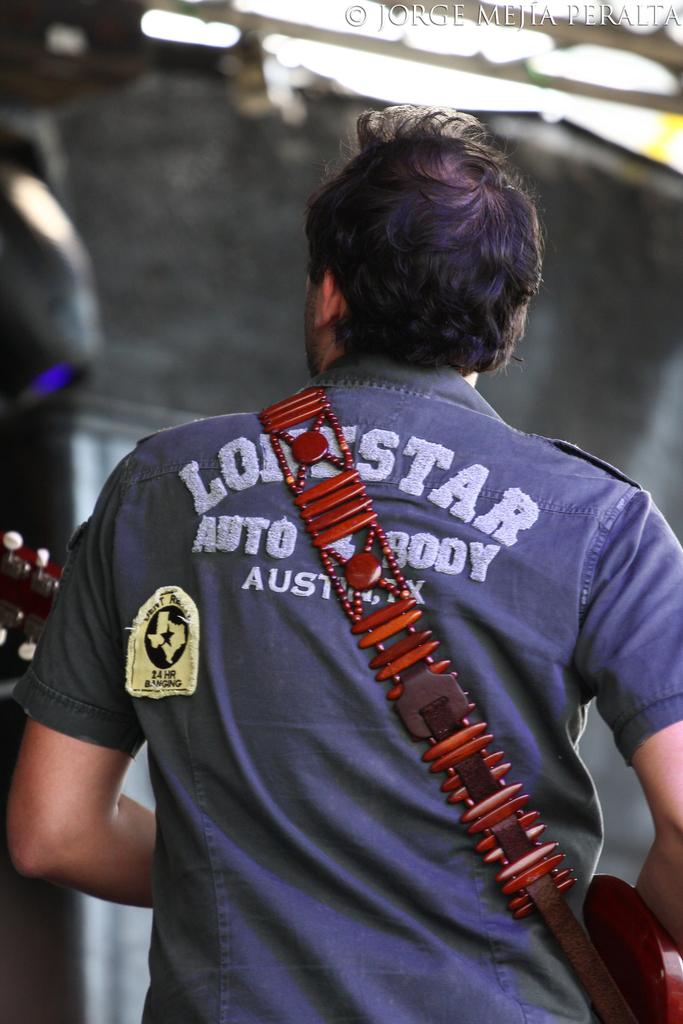What auto body shop is on the shirt?
Provide a succinct answer. Lonestar. 